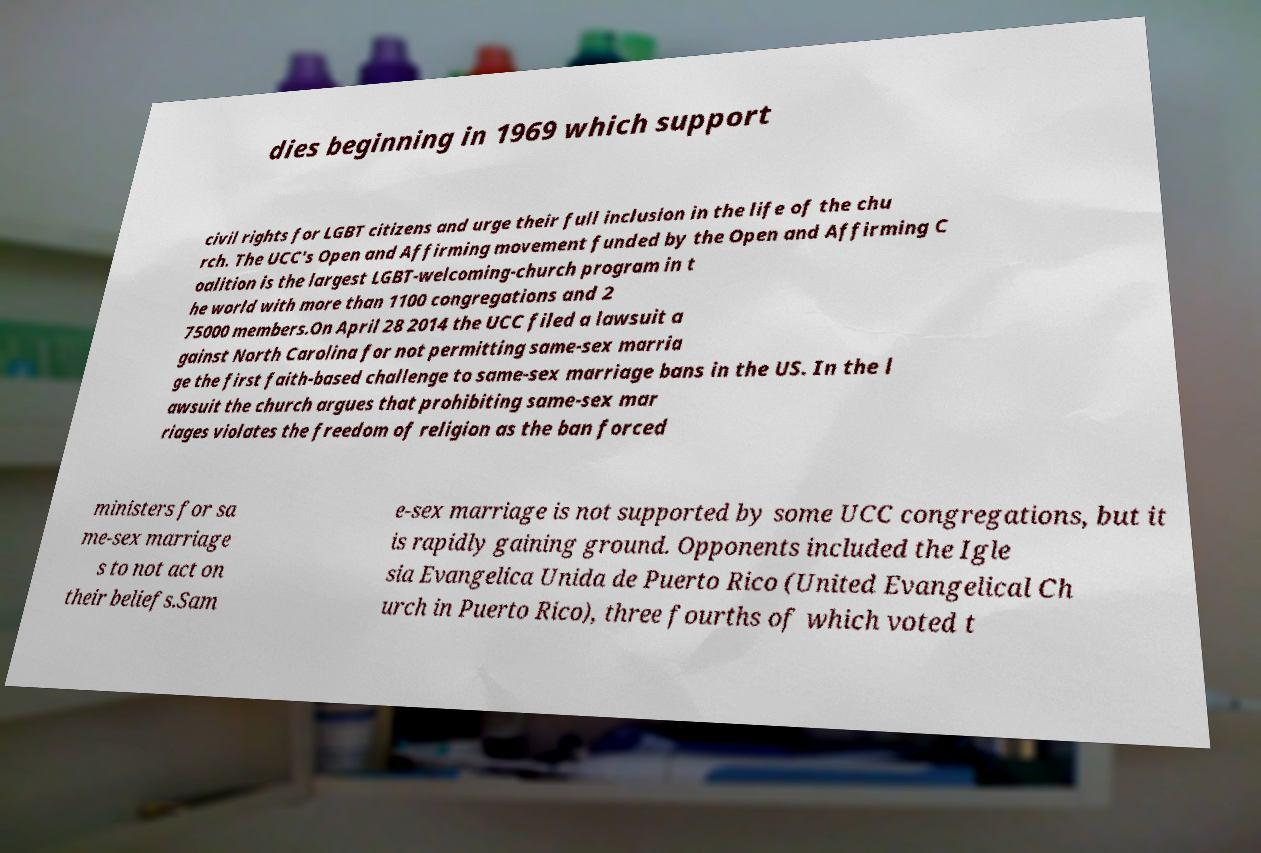Could you assist in decoding the text presented in this image and type it out clearly? dies beginning in 1969 which support civil rights for LGBT citizens and urge their full inclusion in the life of the chu rch. The UCC's Open and Affirming movement funded by the Open and Affirming C oalition is the largest LGBT-welcoming-church program in t he world with more than 1100 congregations and 2 75000 members.On April 28 2014 the UCC filed a lawsuit a gainst North Carolina for not permitting same-sex marria ge the first faith-based challenge to same-sex marriage bans in the US. In the l awsuit the church argues that prohibiting same-sex mar riages violates the freedom of religion as the ban forced ministers for sa me-sex marriage s to not act on their beliefs.Sam e-sex marriage is not supported by some UCC congregations, but it is rapidly gaining ground. Opponents included the Igle sia Evangelica Unida de Puerto Rico (United Evangelical Ch urch in Puerto Rico), three fourths of which voted t 